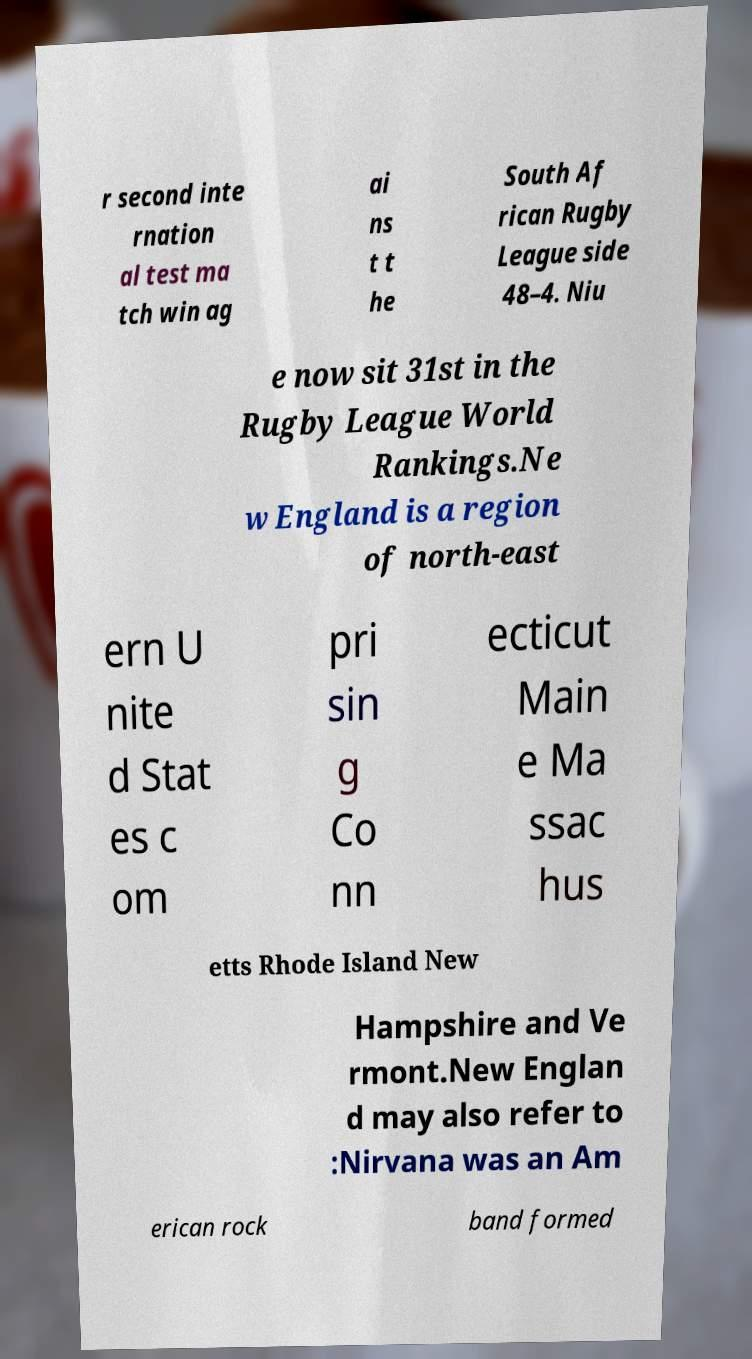I need the written content from this picture converted into text. Can you do that? r second inte rnation al test ma tch win ag ai ns t t he South Af rican Rugby League side 48–4. Niu e now sit 31st in the Rugby League World Rankings.Ne w England is a region of north-east ern U nite d Stat es c om pri sin g Co nn ecticut Main e Ma ssac hus etts Rhode Island New Hampshire and Ve rmont.New Englan d may also refer to :Nirvana was an Am erican rock band formed 